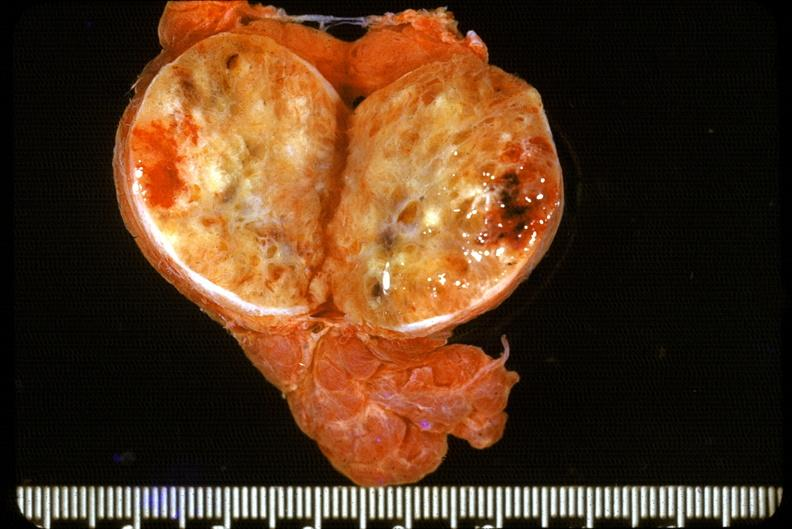where does this belong to?
Answer the question using a single word or phrase. Endocrine system 